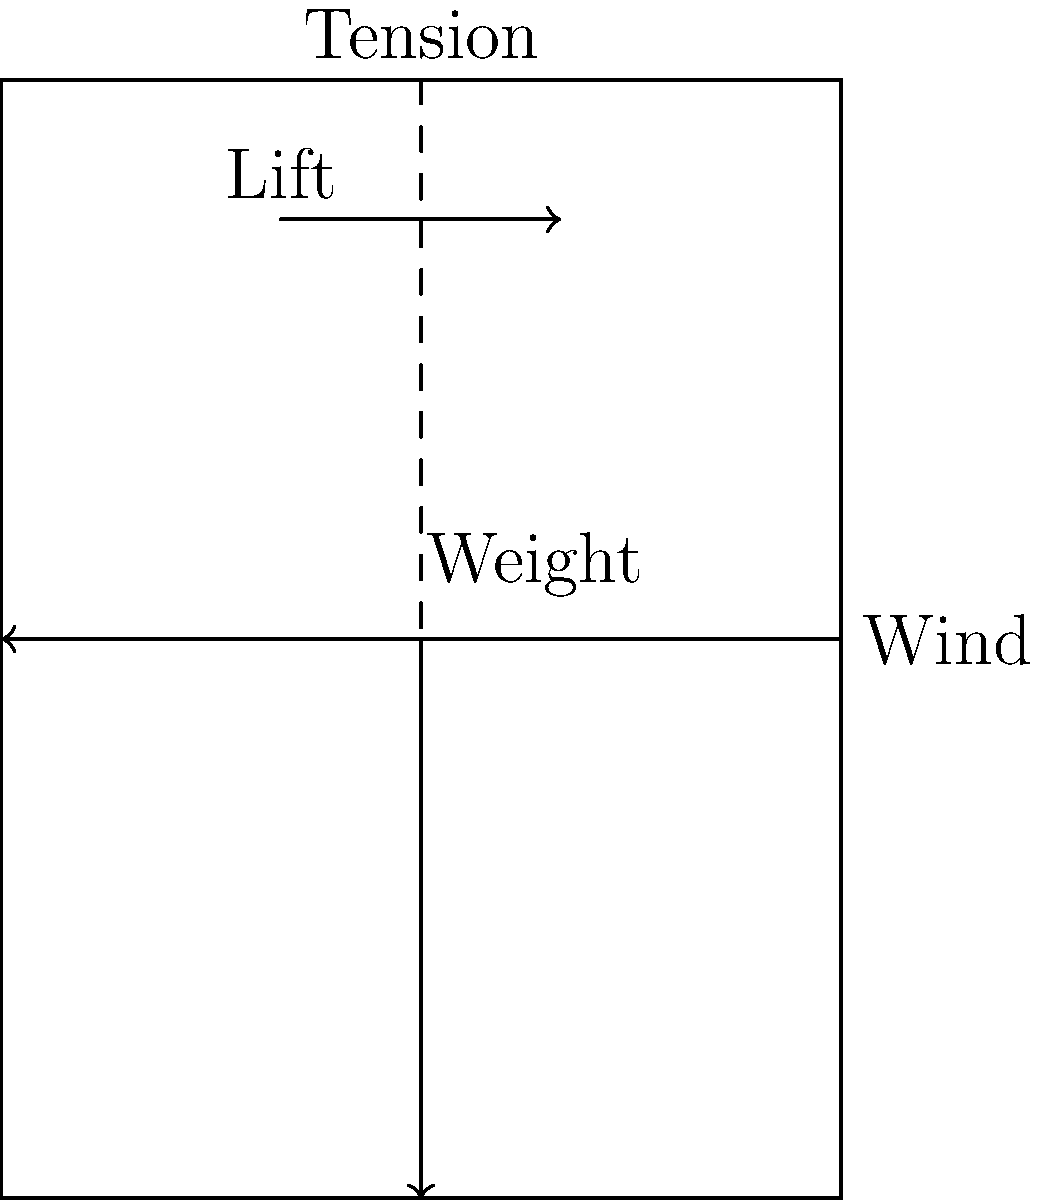A traditional Maori kite, known as manu tukutuku, is flying steadily in the air. The force diagram above represents the forces acting on the kite. If the kite maintains a constant height, what can be concluded about the relationship between the lift force and the weight of the kite? To understand the relationship between the lift force and the weight of the kite when it maintains a constant height, we need to analyze the vertical forces acting on the kite:

1. The two primary vertical forces are:
   a) Lift force (upward)
   b) Weight of the kite (downward)

2. For the kite to maintain a constant height, it must be in equilibrium in the vertical direction. This means that the net force in the vertical direction must be zero.

3. In mathematical terms, for equilibrium:
   $$\sum F_y = 0$$
   where $F_y$ represents the forces in the vertical direction.

4. Applying this to our kite scenario:
   $$F_{lift} - F_{weight} = 0$$

5. Rearranging the equation:
   $$F_{lift} = F_{weight}$$

6. This equality indicates that for the kite to maintain a constant height, the lift force must be exactly equal to the weight of the kite.

7. If the lift force were greater than the weight, the kite would rise. If it were less, the kite would fall.

Therefore, we can conclude that for the Maori kite to fly at a constant height, the lift force must be equal in magnitude to the weight of the kite.
Answer: The lift force is equal to the weight of the kite. 